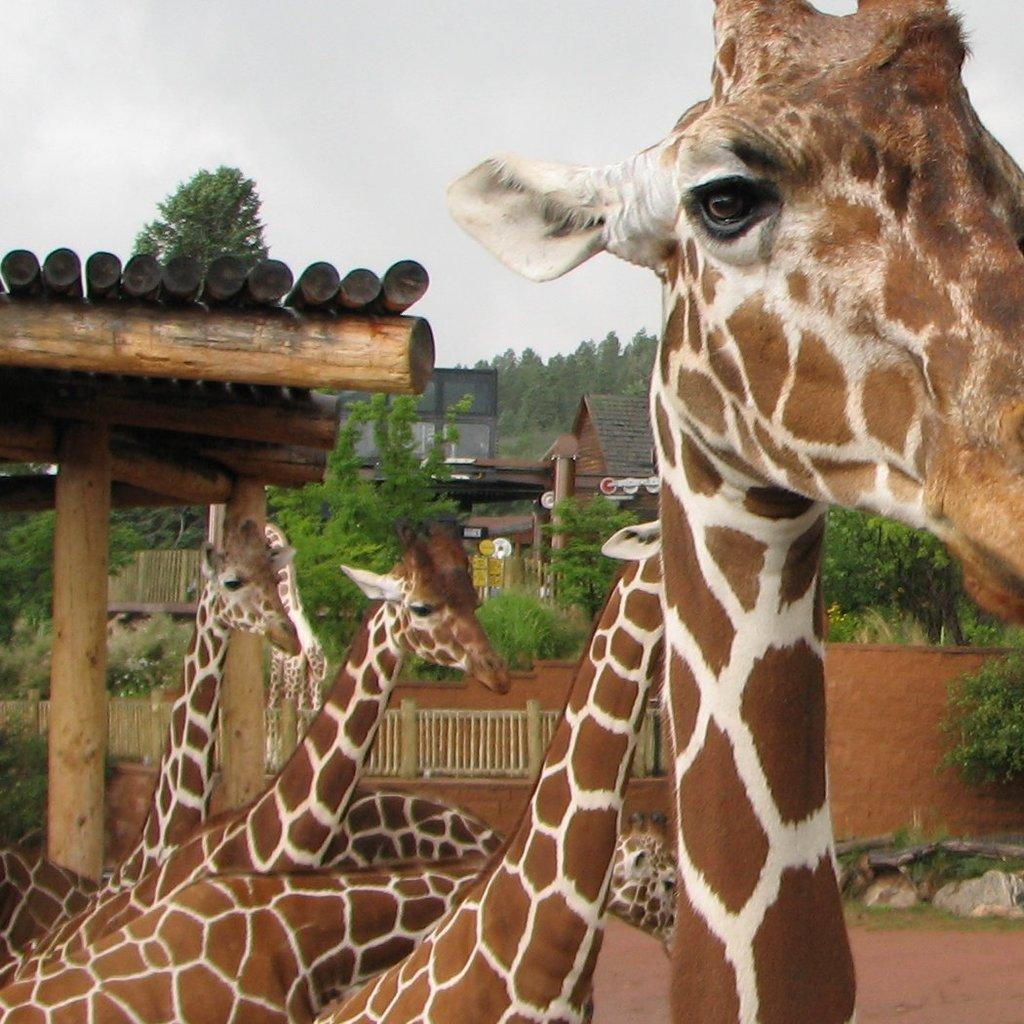How would you summarize this image in a sentence or two? In the image there are few giraffes and behind them there is a shed made up of wooden logs and in the background there are many trees and some houses. 